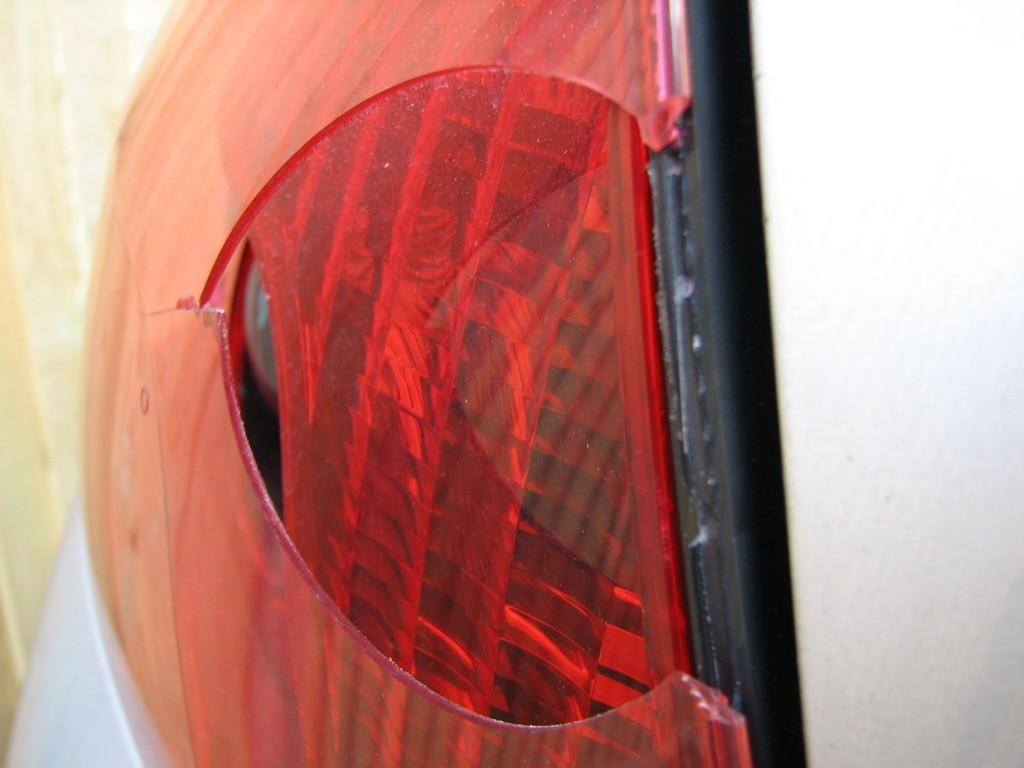What is the main subject of the image? The main subject of the image is a vehicle headlight. Is there a veil covering the vehicle headlight in the image? No, there is no veil present in the image. How many passengers are visible inside the vehicle in the image? There is no vehicle or passengers visible in the image; only the vehicle headlight is present. 